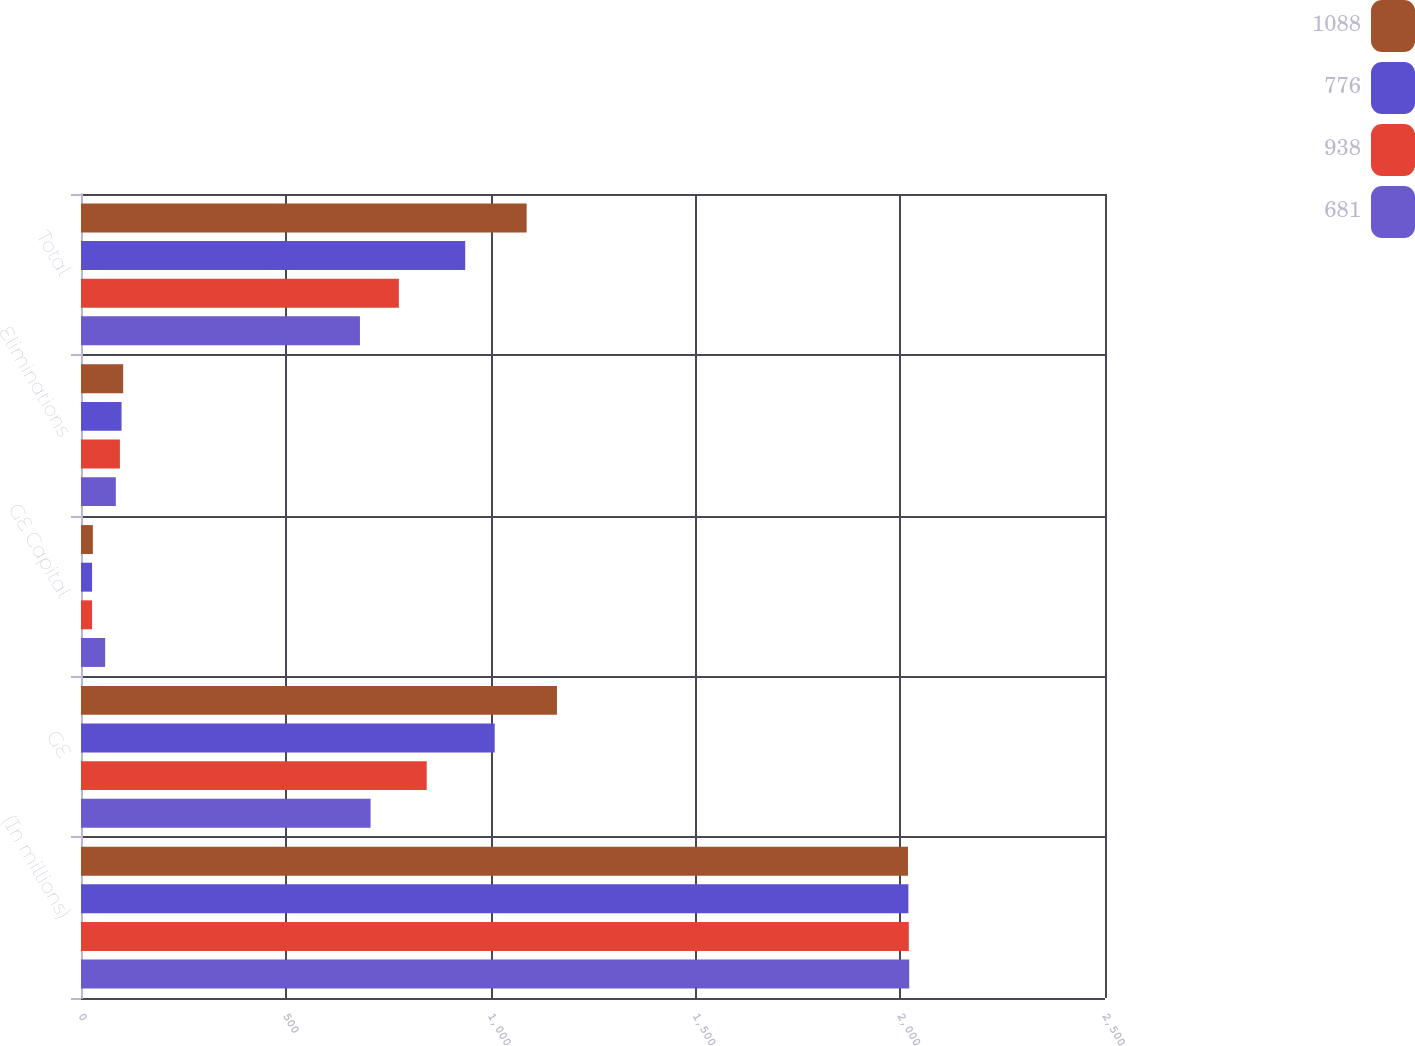<chart> <loc_0><loc_0><loc_500><loc_500><stacked_bar_chart><ecel><fcel>(In millions)<fcel>GE<fcel>GE Capital<fcel>Eliminations<fcel>Total<nl><fcel>1088<fcel>2019<fcel>1162<fcel>29<fcel>103<fcel>1088<nl><fcel>776<fcel>2020<fcel>1010<fcel>27<fcel>99<fcel>938<nl><fcel>938<fcel>2021<fcel>844<fcel>27<fcel>95<fcel>776<nl><fcel>681<fcel>2022<fcel>707<fcel>59<fcel>85<fcel>681<nl></chart> 